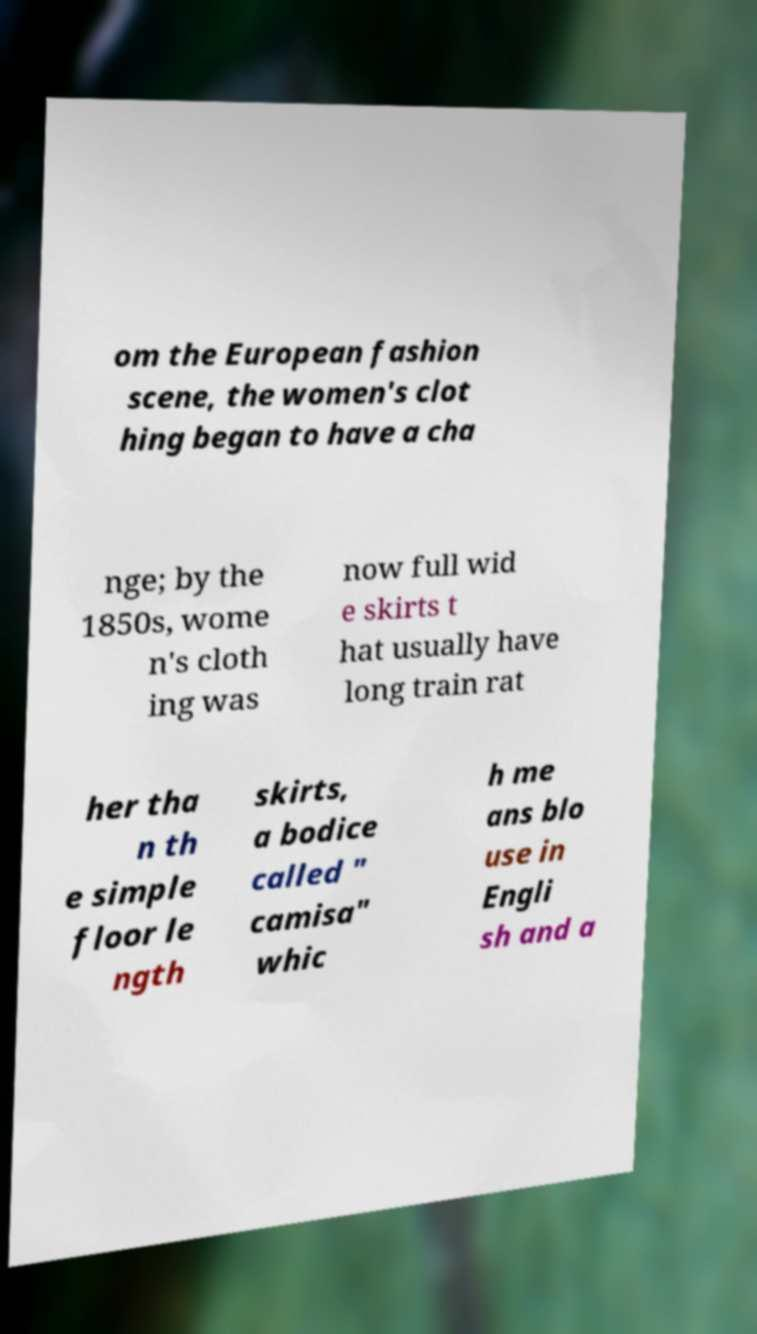Please read and relay the text visible in this image. What does it say? om the European fashion scene, the women's clot hing began to have a cha nge; by the 1850s, wome n's cloth ing was now full wid e skirts t hat usually have long train rat her tha n th e simple floor le ngth skirts, a bodice called " camisa" whic h me ans blo use in Engli sh and a 